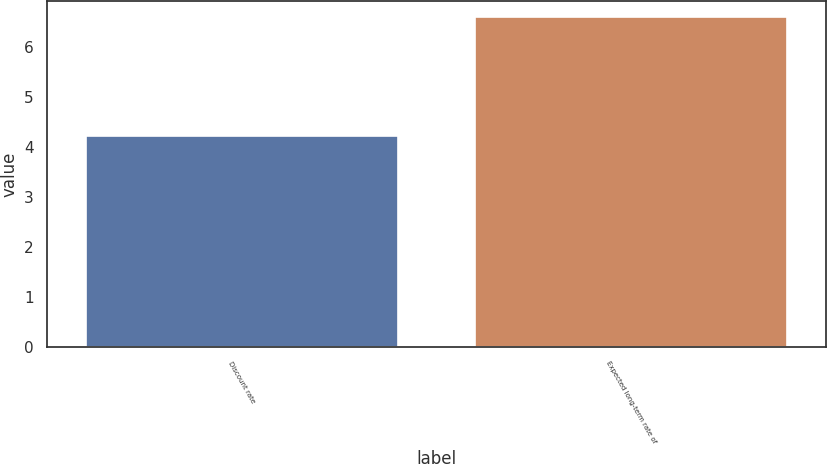Convert chart. <chart><loc_0><loc_0><loc_500><loc_500><bar_chart><fcel>Discount rate<fcel>Expected long-term rate of<nl><fcel>4.22<fcel>6.6<nl></chart> 